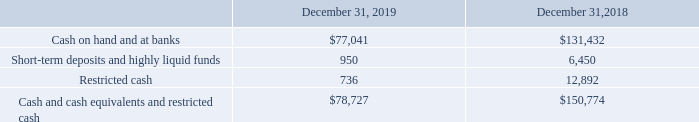NAVIOS MARITIME HOLDINGS INC. NOTES TO THE CONSOLIDATED FINANCIAL STATEMENTS (Expressed in thousands of U.S. dollars — except share data)
NOTE 4: CASH AND CASH EQUIVALENTS AND RESTRICTED CASH
Cash and cash equivalents and restricted cash consisted of the following:
Short-term deposits and highly liquid funds relate to amounts held in banks for general financing purposes and represent deposits with an original maturity of less than three months
Cash deposits and cash equivalents in excess of amounts covered by government-provided insurance are exposed to loss in the event of non-performance by financial institutions. Navios Holdings does maintain cash deposits and equivalents in excess of government provided insurance limits. Navios Holdings reduces exposure to credit risk by dealing with a diversified group of major financial institutions. See also Note 2(e).
What did Short-term deposits and highly liquid funds relate to? Amounts held in banks for general financing purposes and represent deposits with an original maturity of less than three months. Which years does the table provide information for Cash and cash equivalents and restricted cash? 2019, 2018. What was the amount of restricted cash in 2019?
Answer scale should be: thousand. 736. What was the change in Short-term deposits and highly liquid funds between 2018 and 2019?
Answer scale should be: thousand. 950-6,450
Answer: -5500. Which years did Cash and cash equivalents and restricted cash exceed $100,000? (2018:150,774)
Answer: 2018. What was the percentage change in the amount of restricted cash between 2018 and 2019?
Answer scale should be: percent. (736-12,892)/12,892
Answer: -94.29. 